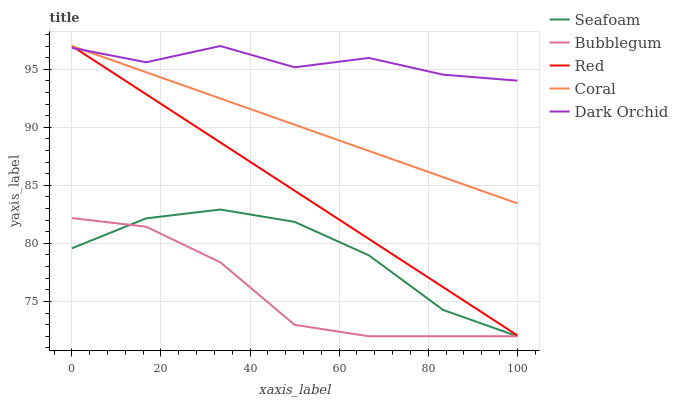Does Red have the minimum area under the curve?
Answer yes or no. No. Does Red have the maximum area under the curve?
Answer yes or no. No. Is Coral the smoothest?
Answer yes or no. No. Is Coral the roughest?
Answer yes or no. No. Does Red have the lowest value?
Answer yes or no. No. Does Seafoam have the highest value?
Answer yes or no. No. Is Seafoam less than Coral?
Answer yes or no. Yes. Is Dark Orchid greater than Seafoam?
Answer yes or no. Yes. Does Seafoam intersect Coral?
Answer yes or no. No. 